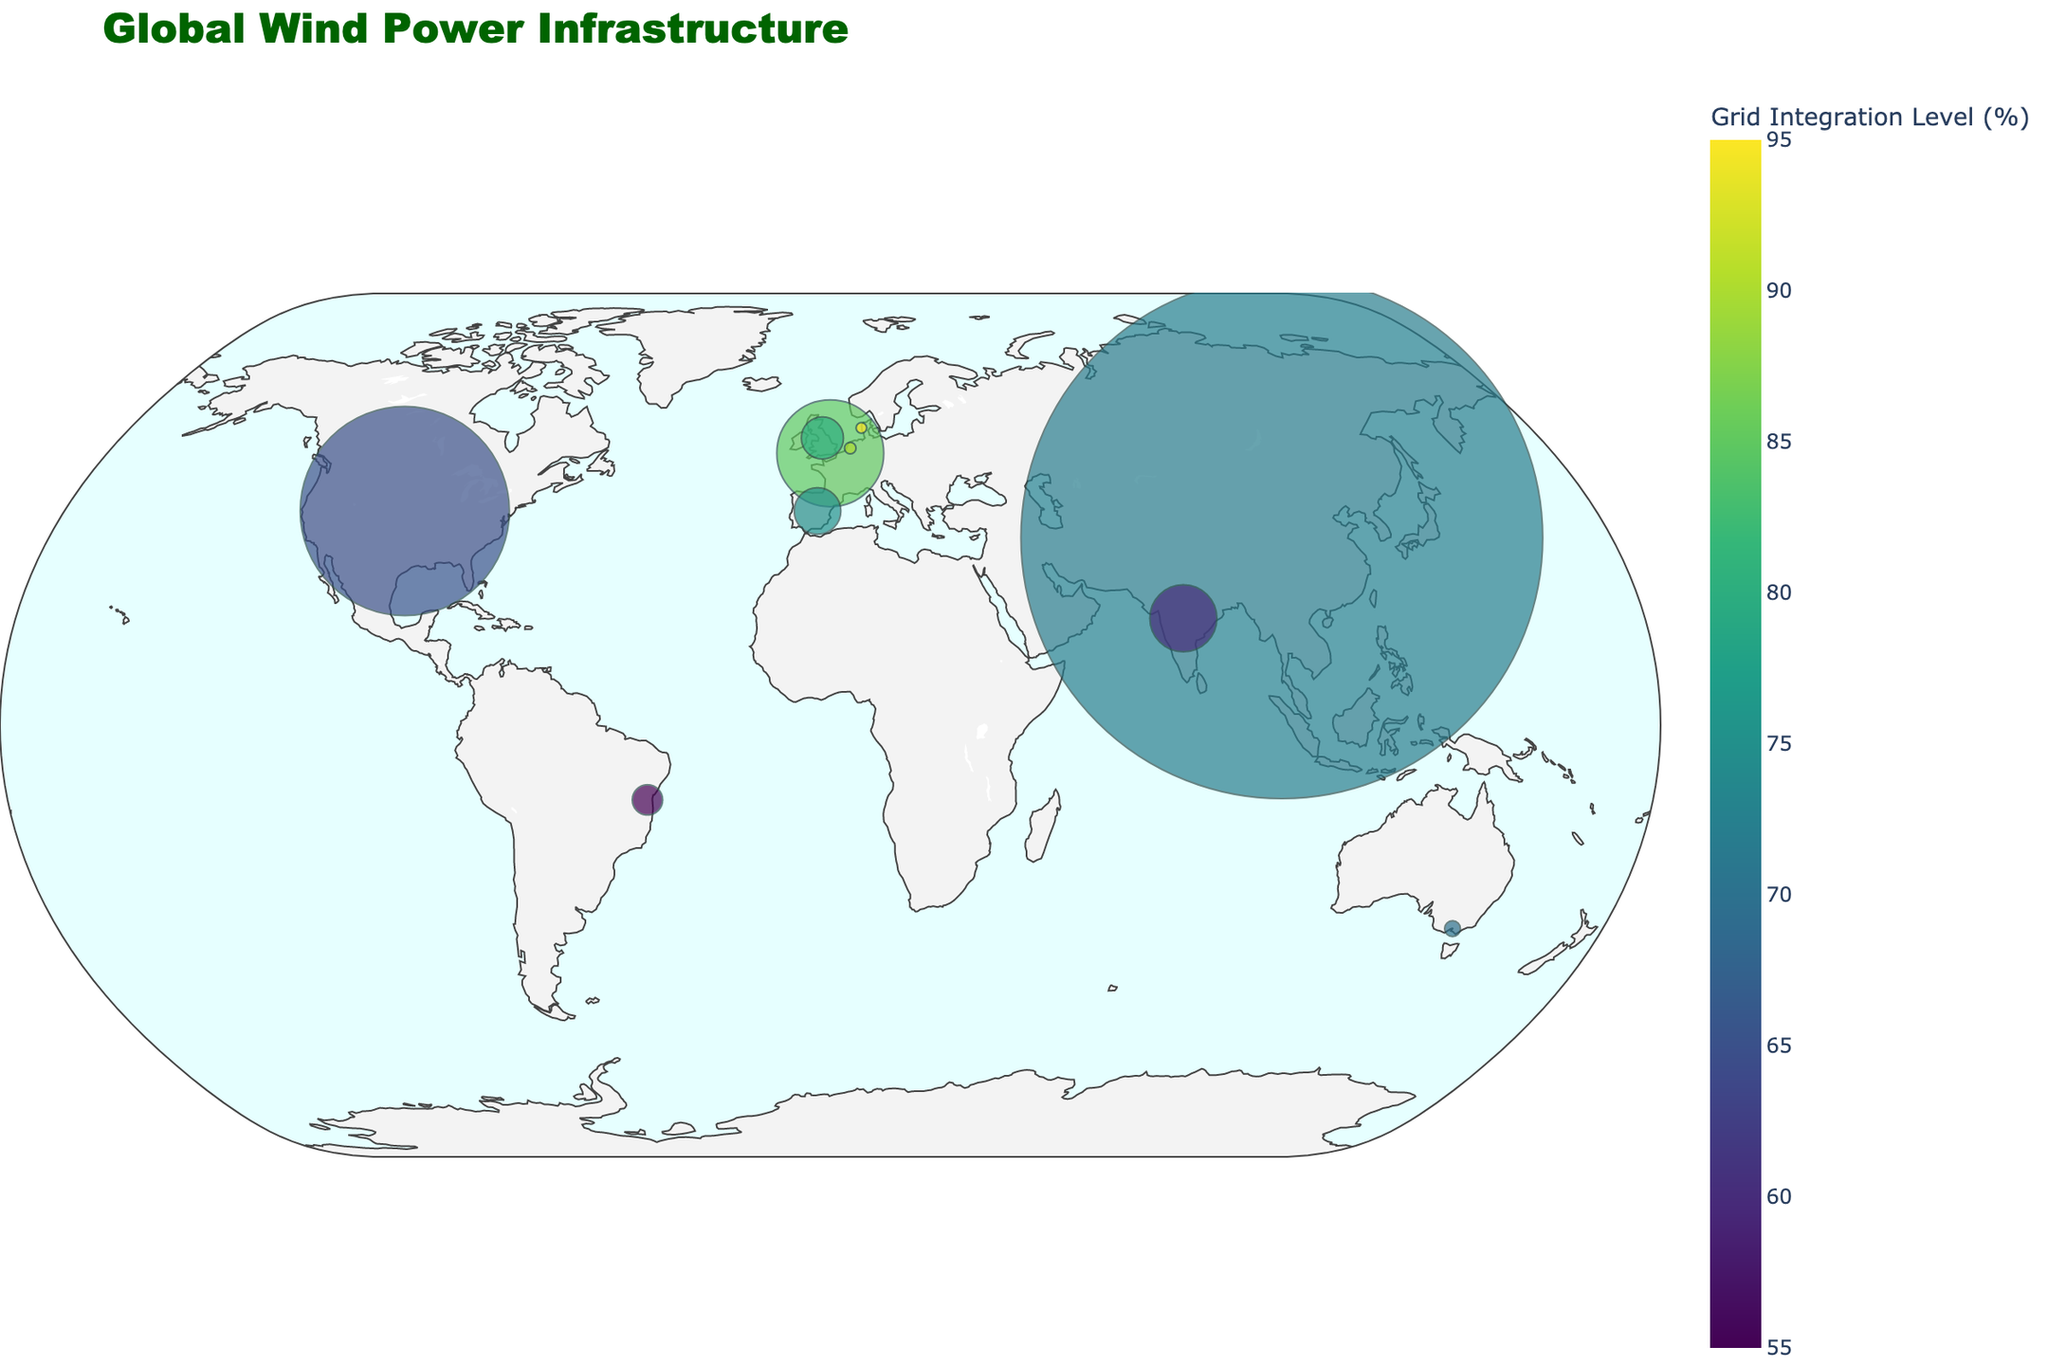How many countries are represented by markers on the plot? The plot indicates one marker per country; count the markers to determine the number of countries.
Answer: 10 Which country has the highest installed wind capacity, and what is the capacity? Look for the largest marker size on the plot, as the marker size represents installed wind capacity, and identify the label that lists the installed wind capacity.
Answer: China, 305670 MW Among the countries shown, which one has the highest grid integration level for wind power, and what is that percentage? Examine the color of the markers which represents the grid integration level, and hover over the markers to find the percentage.
Answer: Denmark, 95% What is the combined transmission lines length of Germany, Spain, and the Netherlands? Add the transmission lines lengths of Germany (36000 km), Spain (44000 km), and the Netherlands (3000 km).
Answer: 83000 km Compare the grid integration levels of Australia and India. Which country has a higher level, and by how much? Look at the colors of the markers for Australia and India and identify the grid integration levels by hovering over them. Subtract to find the difference.
Answer: Australia has 10% higher Which country, represented on the plot, has the lowest transmission lines length and what is that length? Hover over each marker and identify the country with the lowest transmission lines length in kilometers.
Answer: Netherlands, 3000 km If you identify the country with the highest grid integration level, what is the name of its notable wind farm? Hover over the marker of the country with the highest grid integration level and read the notable wind farm information.
Answer: Horns Rev 3 (Denmark) What is the average installed wind capacity of the countries shown on the plot? Sum the installed wind capacities of all the countries and divide by the number of countries (10).
Answer: 67693.8 MW Which two countries combined have a grid integration level equal to the sum of that of Brazil and the United Kingdom? Find and add the grid integration levels of Brazil (55%) and the United Kingdom (80%) first, then identify two countries whose grid integration levels sum to 135%.
Answer: Germany and Netherlands (85% + 90%) What transmission lines length is associated with the Alta Wind Energy Center? Find the country in the plot that lists the Alta Wind Energy Center, then read the transmission lines length from the associated information.
Answer: 257000 km (United States) 